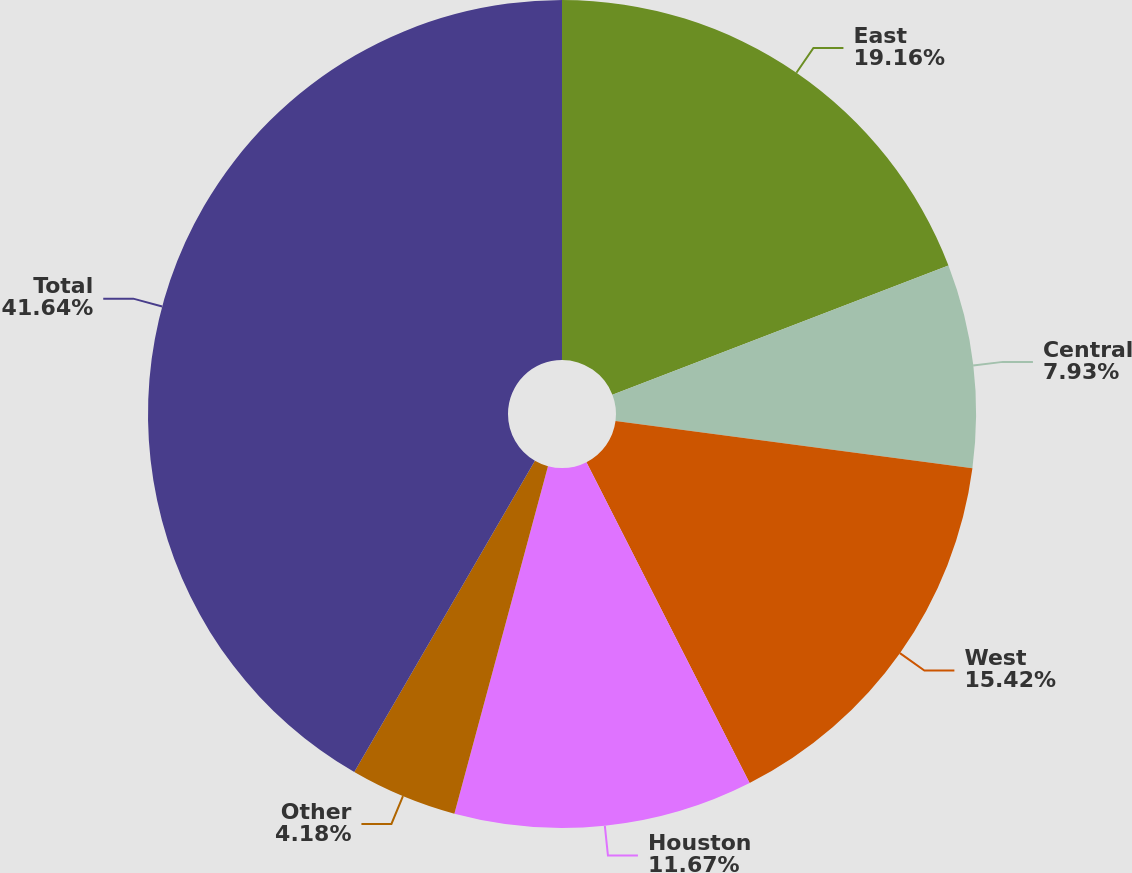<chart> <loc_0><loc_0><loc_500><loc_500><pie_chart><fcel>East<fcel>Central<fcel>West<fcel>Houston<fcel>Other<fcel>Total<nl><fcel>19.16%<fcel>7.93%<fcel>15.42%<fcel>11.67%<fcel>4.18%<fcel>41.63%<nl></chart> 